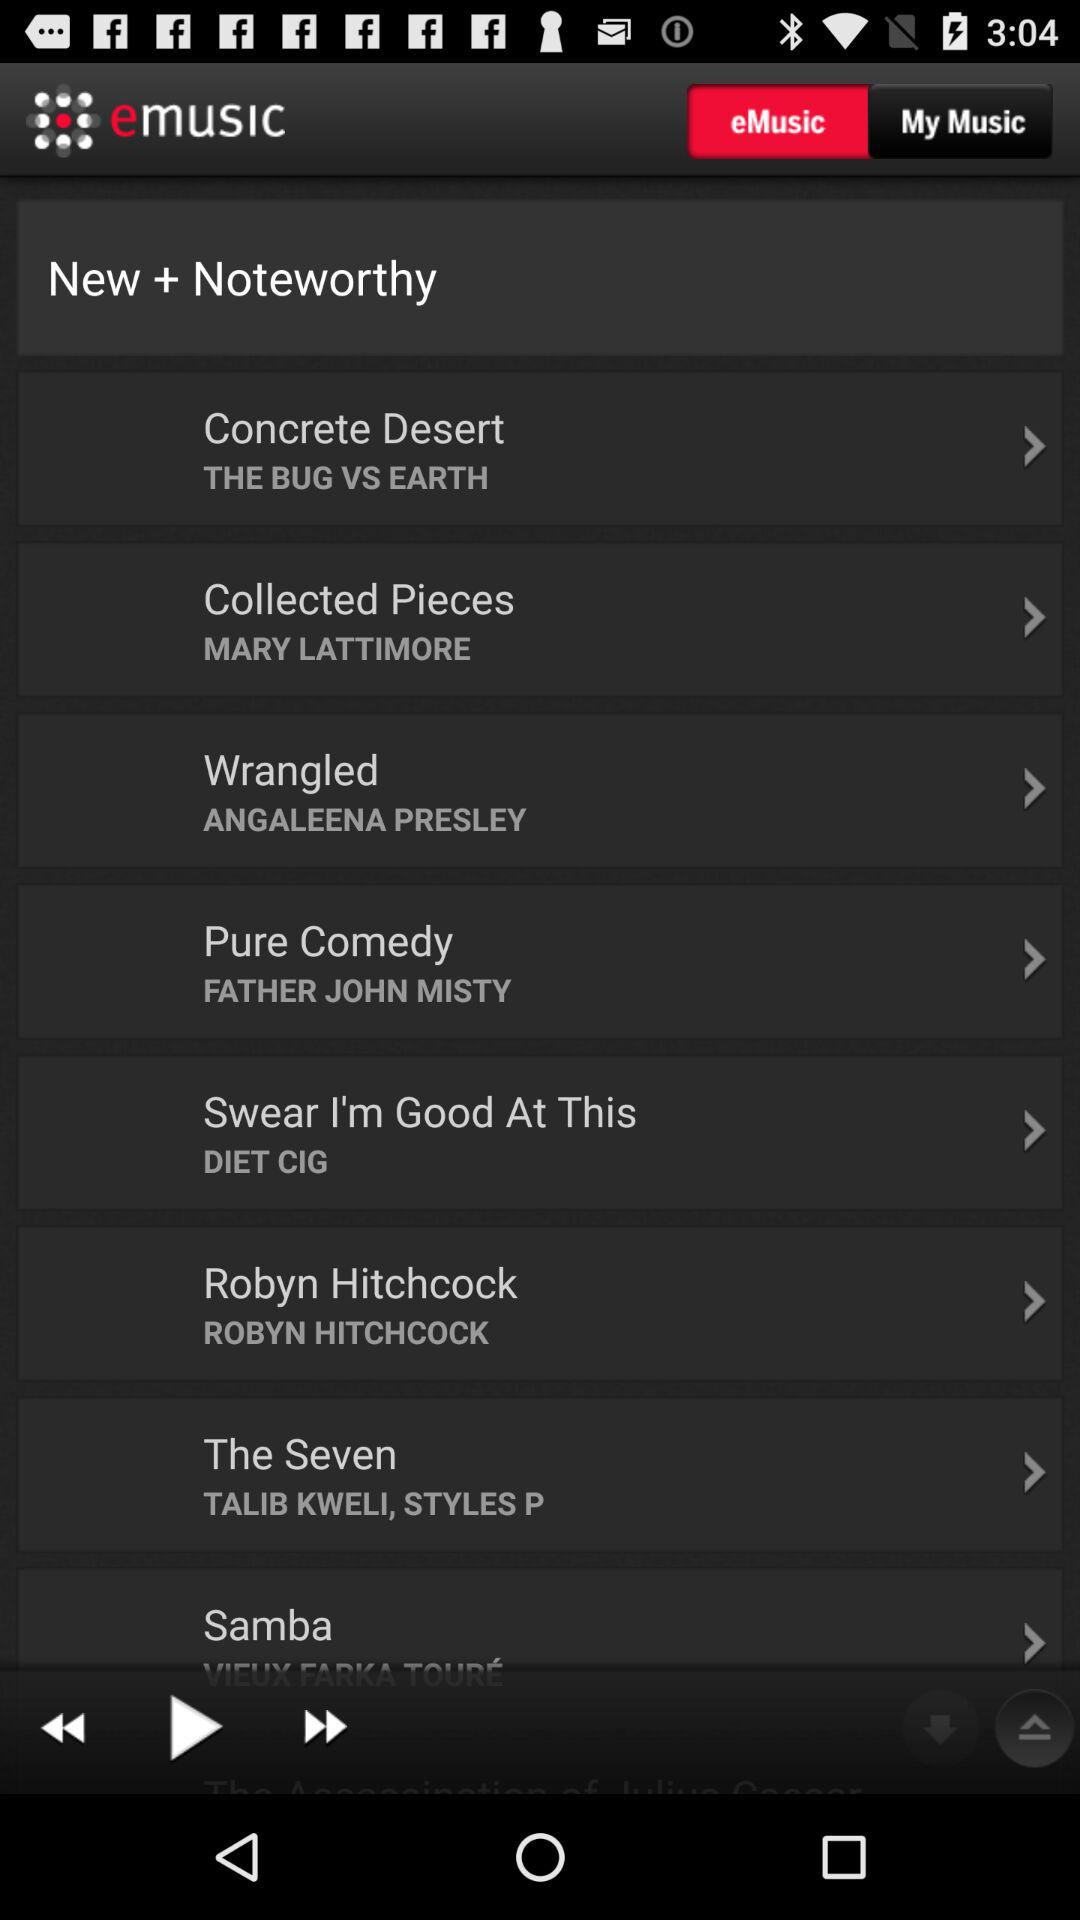Who is the artist of "Pure Comedy"? The artist of "Pure Comedy" is Father John Misty. 